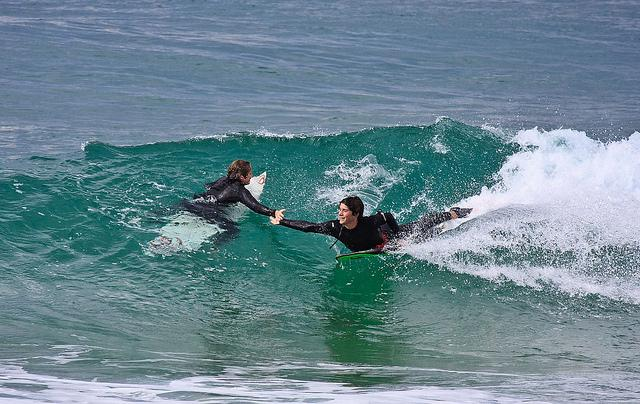What are the people holding? Please explain your reasoning. hands. The people are each holding out a hand. 